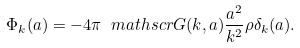<formula> <loc_0><loc_0><loc_500><loc_500>\Phi _ { k } ( a ) = - 4 \pi \ m a t h s c r G ( k , a ) \frac { a ^ { 2 } } { k ^ { 2 } } \rho \delta _ { k } ( a ) .</formula> 